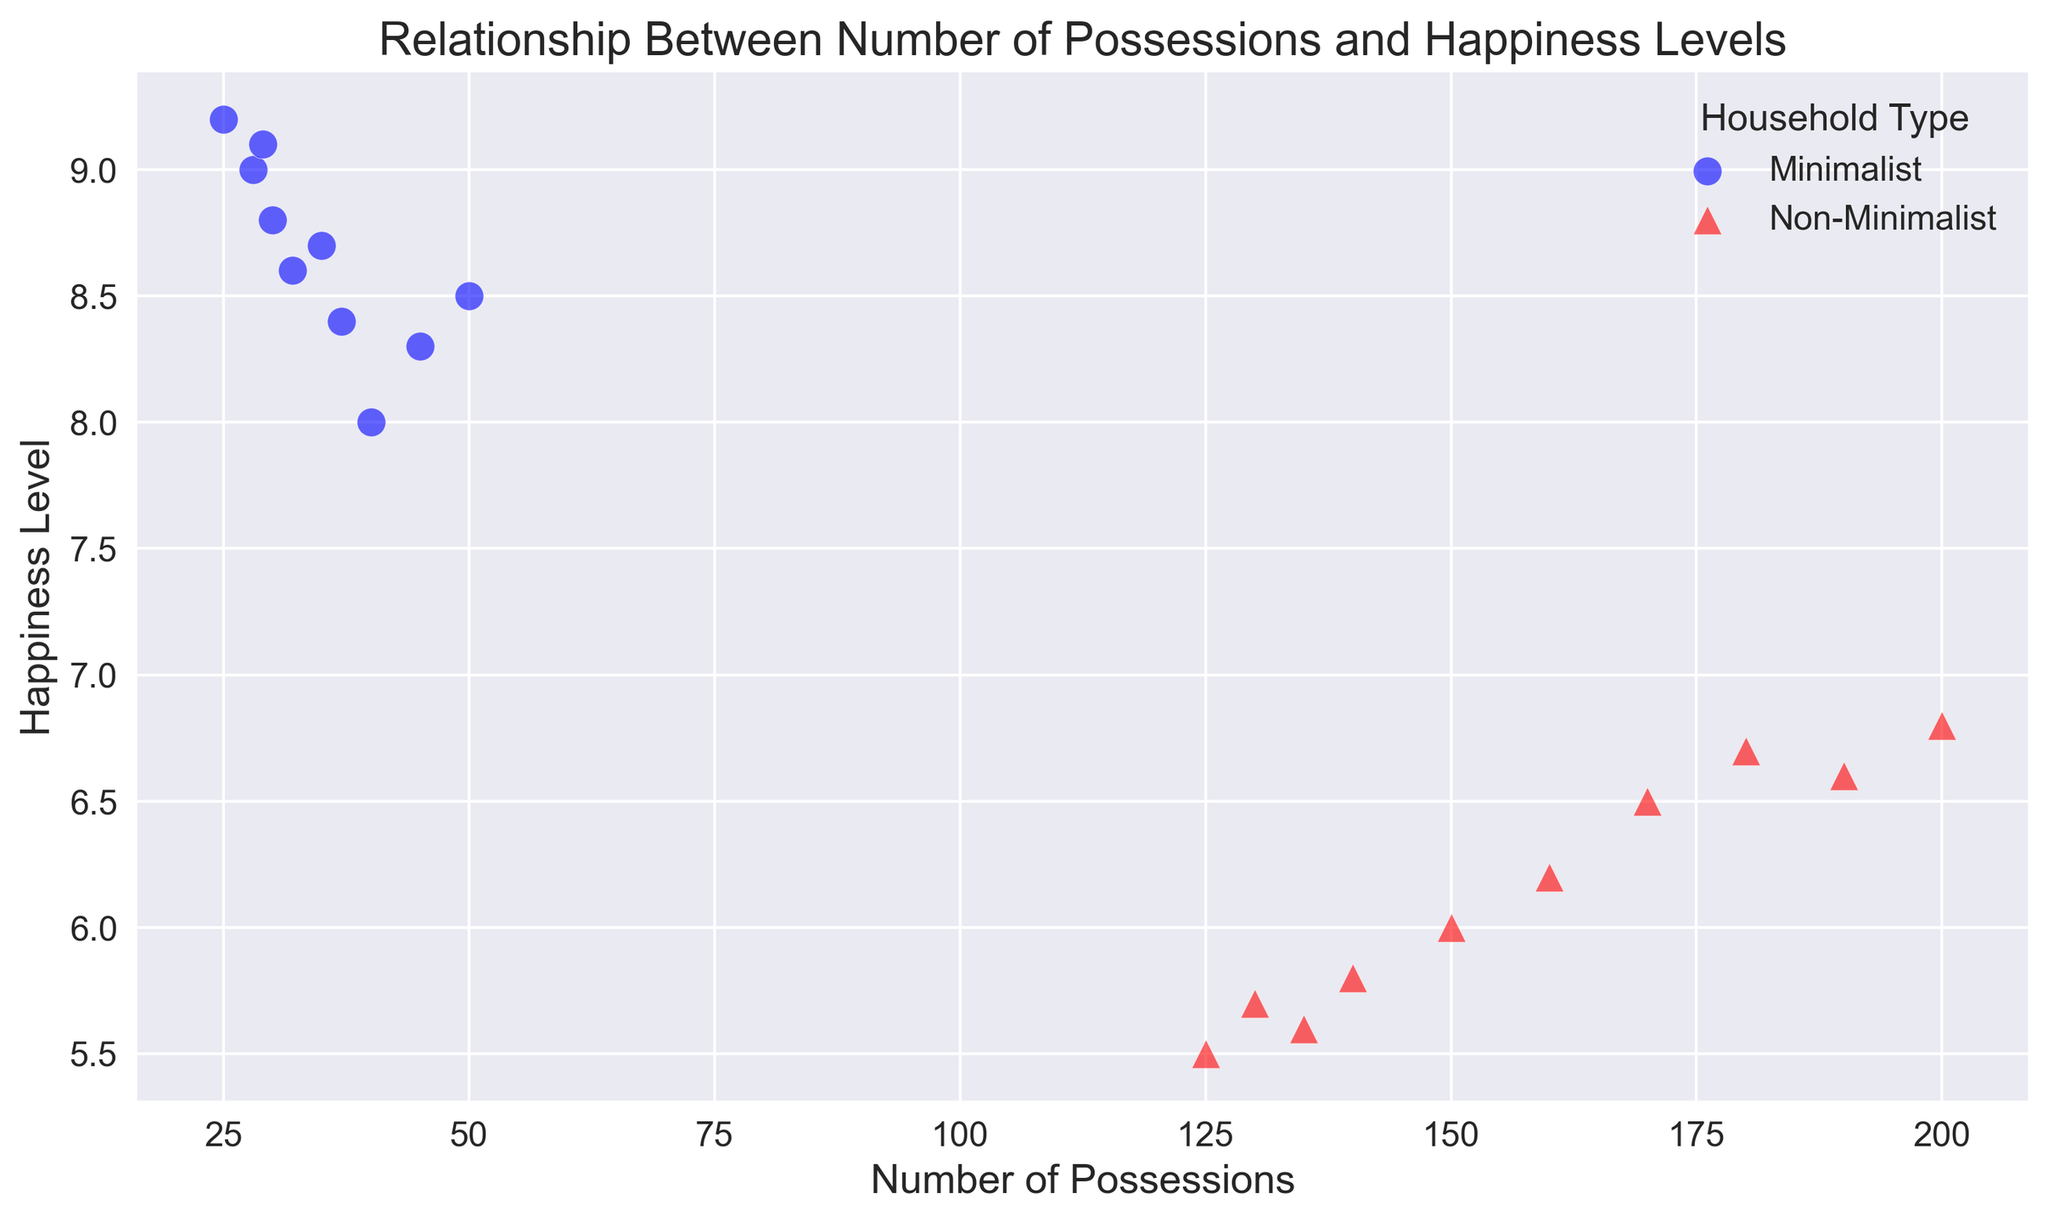What is the maximum happiness level reported by minimalist households? The maximal happiness level for minimalist households corresponds to the highest y-value among blue circles. The highest y-value for minimalist households is 9.2.
Answer: 9.2 What is the range of the number of possessions for non-minimalist households? The range is the difference between the highest and lowest number of possessions for red triangles. The lowest is 125, and the highest is 200. So the range is 200 - 125 = 75.
Answer: 75 Which household type generally shows higher happiness levels? Compare the general position of blue circles and red triangles on the y-axis. The blue circles (minimalist) are positioned higher on the y-axis overall, indicating higher happiness levels compared to red triangles (non-minimalist).
Answer: Minimalist For minimalist households, what is the average number of possessions? Sum the number of possessions for minimalist households and divide by the number of data points. The sum is 50 + 40 + 45 + 30 + 35 + 28 + 32 + 25 + 37 + 29 = 351. The number of data points is 10. So, the average is 351/10 = 35.1.
Answer: 35.1 Are there any non-minimalist households with happiness levels above 7? Look for red triangles (non-minimalist) with y-values above 7. None of the red triangles are above a y-value of 7; their maximum is 6.8.
Answer: No Which household type has the smallest number of possessions, and what is it? Identify the smallest x-value represented by both blue circles and red triangles. The smallest x-value is 25, which corresponds to a blue circle (minimalist household).
Answer: Minimalist, 25 How does the variation in happiness levels compare between minimalist and non-minimalist households? Identify the range of y-values for both blue circles (minimalist) and red triangles (non-minimalist). Minimalist households range from 8.0 to 9.2, whereas non-minimalist households range from 5.5 to 6.8. Minimalist households have a larger range.
Answer: Minimalist have a larger range What is the difference between the average happiness levels of minimalist and non-minimalist households? Calculate average happiness for both: Minimalist = (8.5 + 8.0 + 8.3 + 8.8 + 8.7 + 9.0 + 8.6 + 9.2 + 8.4 + 9.1)/10 = 8.66. Non-minimalist = (6.0 + 6.2 + 5.8 + 6.5 + 5.7 + 6.7 + 5.5 + 6.8 + 5.6 + 6.6)/10 = 6.14. The difference is 8.66 - 6.14 = 2.52.
Answer: 2.52 